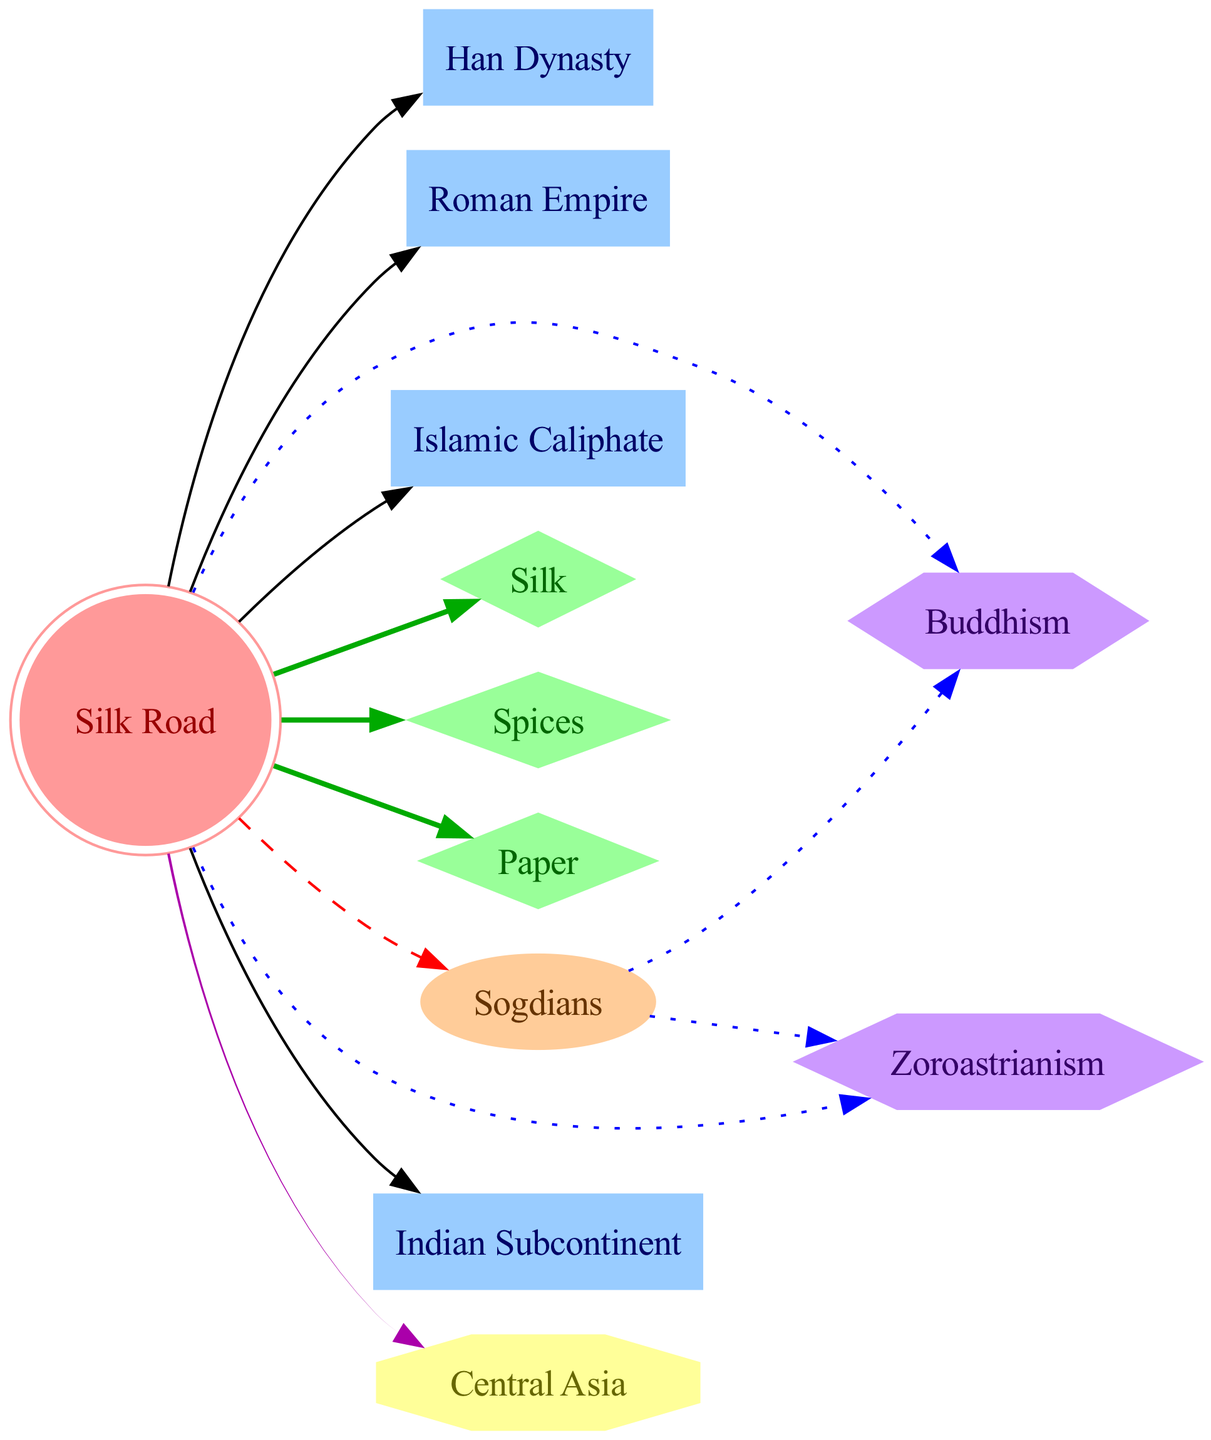What is the central node of the diagram? The central node, representing the core concept of the diagram, is labeled "Silk Road." It is the primary focus around which all other nodes are connected.
Answer: Silk Road How many types of goods are represented in the diagram? The diagram includes three types of goods: Silk, Spices, and Paper. This can be determined by counting the nodes categorized as "good."
Answer: 3 Which tribe is identified as mediators along the Silk Road? The node labeled "Sogdians" is connected to the Silk Road node with the relationship "mediators," indicating their role in facilitating cultural exchanges.
Answer: Sogdians What religion spread via the Sogdians according to the diagram? Both Buddhism and Zoroastrianism are indicated to have spread through the Sogdians as they are directly connected to the Sogdians with a relationship of "spread."
Answer: Buddhism, Zoroastrianism Which two empires are directly connected to the Silk Road? The Han Dynasty and the Roman Empire are both directly connected to the Silk Road node, showing their geographical and cultural ties to this trade route.
Answer: Han Dynasty, Roman Empire What type of relationship exists between "Silk" and "Silk Road"? The relationship between Silk and Silk Road is categorized as "trade," indicating that Silk is one of the goods that were exchanged along the Silk Road.
Answer: trade How many ideas are mentioned in the diagram? The diagram identifies two ideas: Buddhism and Zoroastrianism, which are classified under the type "idea." By examining the nodes, we find these two are present.
Answer: 2 Which region is emphasized in the diagram and linked to the Silk Road? The region labeled "Central Asia" is directly connected to the Silk Road, showcasing its geographical significance in the context of the cultural exchanges.
Answer: Central Asia 